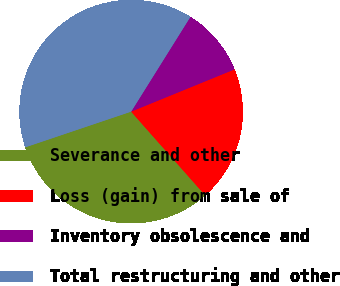<chart> <loc_0><loc_0><loc_500><loc_500><pie_chart><fcel>Severance and other<fcel>Loss (gain) from sale of<fcel>Inventory obsolescence and<fcel>Total restructuring and other<nl><fcel>31.35%<fcel>19.65%<fcel>9.93%<fcel>39.07%<nl></chart> 